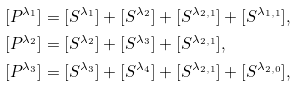Convert formula to latex. <formula><loc_0><loc_0><loc_500><loc_500>[ P ^ { \lambda _ { 1 } } ] & = [ S ^ { \lambda _ { 1 } } ] + [ S ^ { \lambda _ { 2 } } ] + [ S ^ { \lambda _ { 2 , 1 } } ] + [ S ^ { \lambda _ { 1 , 1 } } ] , \\ [ P ^ { \lambda _ { 2 } } ] & = [ S ^ { \lambda _ { 2 } } ] + [ S ^ { \lambda _ { 3 } } ] + [ S ^ { \lambda _ { 2 , 1 } } ] , \\ [ P ^ { \lambda _ { 3 } } ] & = [ S ^ { \lambda _ { 3 } } ] + [ S ^ { \lambda _ { 4 } } ] + [ S ^ { \lambda _ { 2 , 1 } } ] + [ S ^ { \lambda _ { 2 , 0 } } ] ,</formula> 